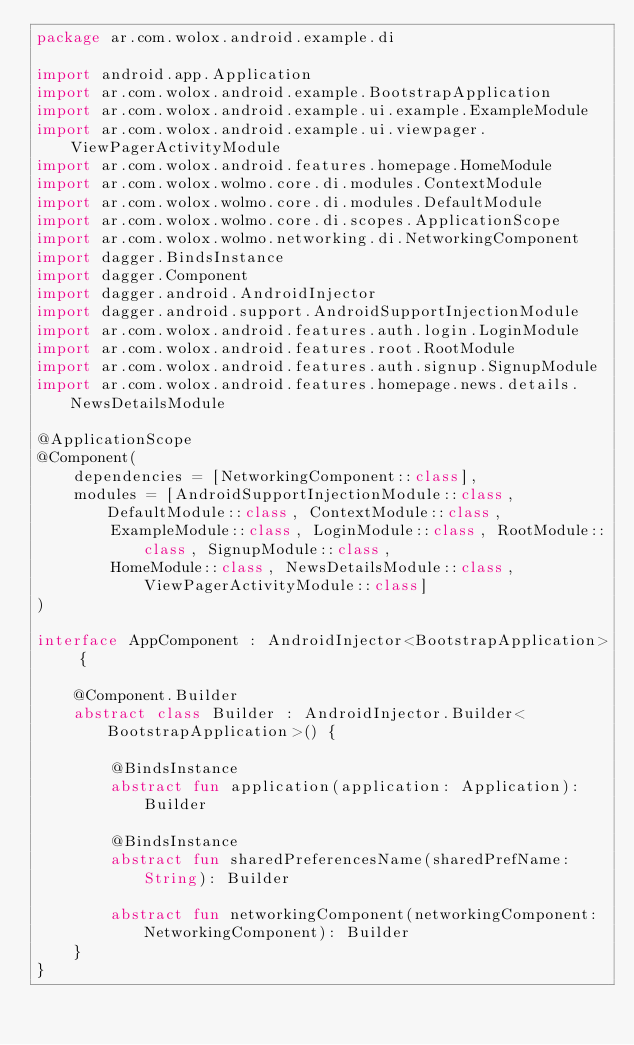Convert code to text. <code><loc_0><loc_0><loc_500><loc_500><_Kotlin_>package ar.com.wolox.android.example.di

import android.app.Application
import ar.com.wolox.android.example.BootstrapApplication
import ar.com.wolox.android.example.ui.example.ExampleModule
import ar.com.wolox.android.example.ui.viewpager.ViewPagerActivityModule
import ar.com.wolox.android.features.homepage.HomeModule
import ar.com.wolox.wolmo.core.di.modules.ContextModule
import ar.com.wolox.wolmo.core.di.modules.DefaultModule
import ar.com.wolox.wolmo.core.di.scopes.ApplicationScope
import ar.com.wolox.wolmo.networking.di.NetworkingComponent
import dagger.BindsInstance
import dagger.Component
import dagger.android.AndroidInjector
import dagger.android.support.AndroidSupportInjectionModule
import ar.com.wolox.android.features.auth.login.LoginModule
import ar.com.wolox.android.features.root.RootModule
import ar.com.wolox.android.features.auth.signup.SignupModule
import ar.com.wolox.android.features.homepage.news.details.NewsDetailsModule

@ApplicationScope
@Component(
    dependencies = [NetworkingComponent::class],
    modules = [AndroidSupportInjectionModule::class, DefaultModule::class, ContextModule::class,
        ExampleModule::class, LoginModule::class, RootModule::class, SignupModule::class,
        HomeModule::class, NewsDetailsModule::class, ViewPagerActivityModule::class]
)

interface AppComponent : AndroidInjector<BootstrapApplication> {

    @Component.Builder
    abstract class Builder : AndroidInjector.Builder<BootstrapApplication>() {

        @BindsInstance
        abstract fun application(application: Application): Builder

        @BindsInstance
        abstract fun sharedPreferencesName(sharedPrefName: String): Builder

        abstract fun networkingComponent(networkingComponent: NetworkingComponent): Builder
    }
}
</code> 